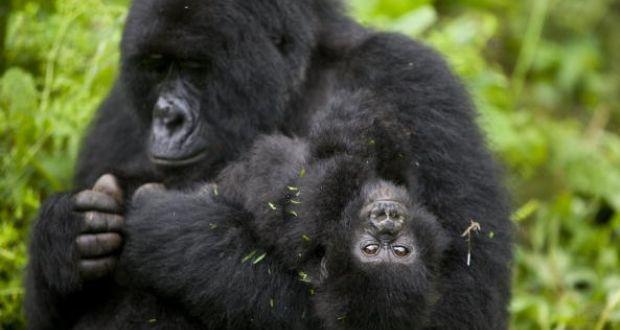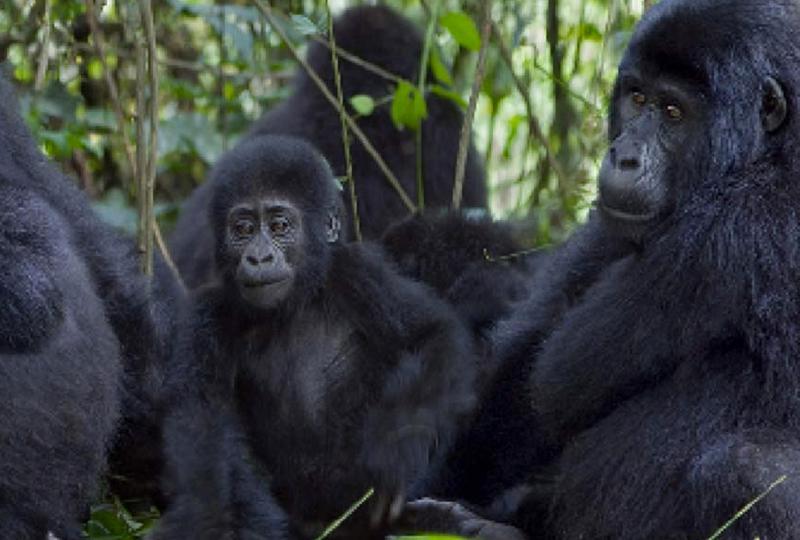The first image is the image on the left, the second image is the image on the right. Assess this claim about the two images: "There are no more than two gorillas in the right image.". Correct or not? Answer yes or no. No. The first image is the image on the left, the second image is the image on the right. Considering the images on both sides, is "There are adult and juvenile gorillas in each image." valid? Answer yes or no. Yes. 